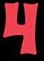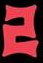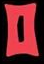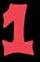Read the text content from these images in order, separated by a semicolon. 4; 2; 0; 1 